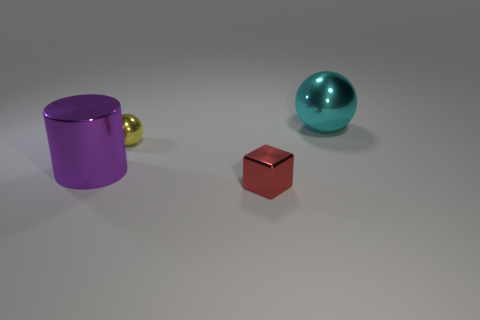What number of cyan things are big shiny balls or things?
Ensure brevity in your answer.  1. How many metal objects are both in front of the cyan ball and behind the small red metal cube?
Your answer should be compact. 2. Does the large purple cylinder have the same material as the big cyan thing?
Ensure brevity in your answer.  Yes. There is a cyan shiny thing that is the same size as the cylinder; what is its shape?
Make the answer very short. Sphere. Are there more tiny metal blocks than large shiny things?
Provide a succinct answer. No. How many other things are the same material as the tiny sphere?
Ensure brevity in your answer.  3. There is a yellow shiny object behind the tiny metal object that is in front of the small thing behind the small red object; what size is it?
Offer a very short reply. Small. How many shiny objects are either small brown spheres or small red cubes?
Make the answer very short. 1. There is a cyan metallic thing; does it have the same shape as the tiny thing that is behind the metal cube?
Provide a short and direct response. Yes. Is the number of tiny metallic balls left of the tiny cube greater than the number of small yellow metal balls that are on the left side of the tiny yellow metallic sphere?
Your response must be concise. Yes. 